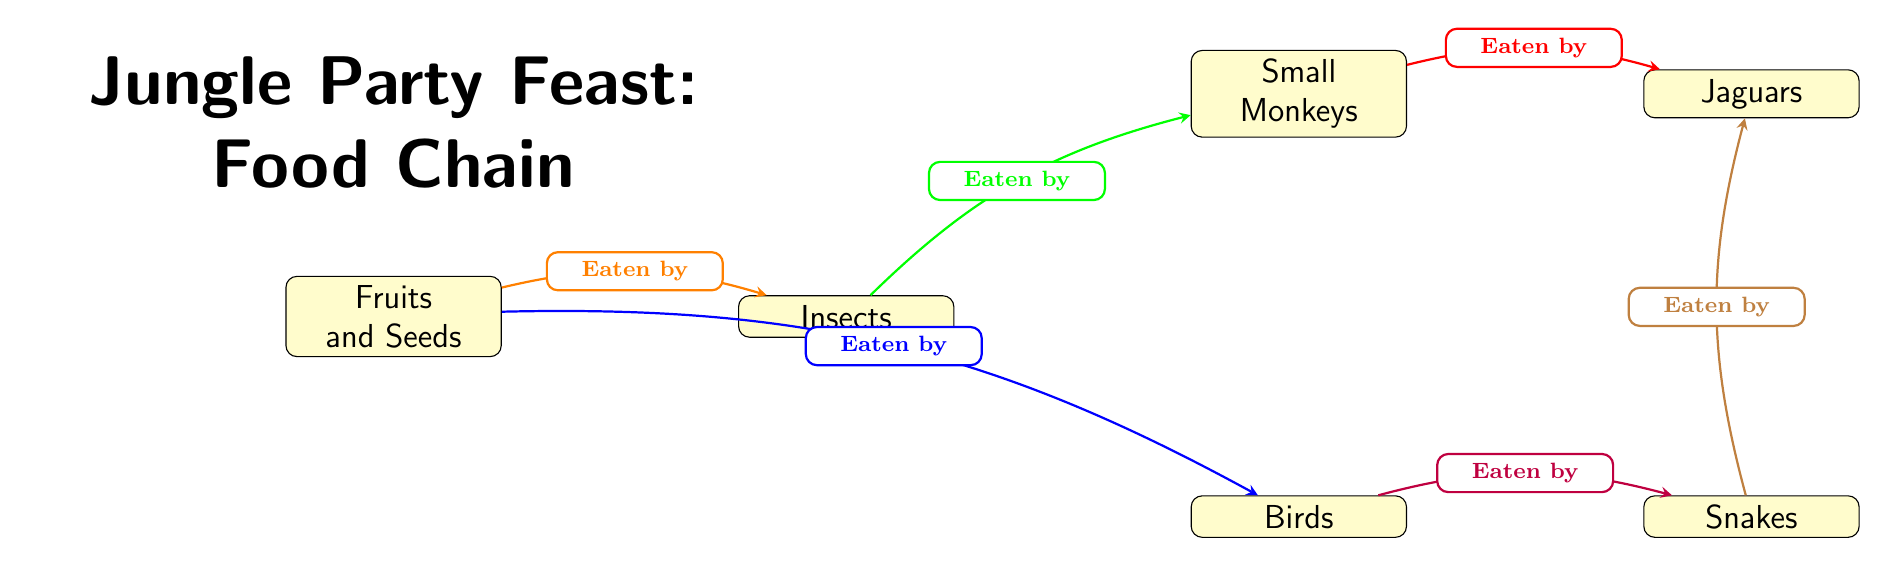What's at the top of the food chain? The diagram shows that Jaguars are positioned at the top of the food chain, indicating they are the largest predators.
Answer: Jaguars How many nodes are in the food chain? Counting each of the distinct entities in the diagram, we identify Fruits and Seeds, Insects, Small Monkeys, Birds, Snakes, and Jaguars, which totals six nodes.
Answer: 6 What do insects eat? Referring to the diagram, it's clear that Insects eat Fruits and Seeds, which is indicated by the arrow pointing from Fruits and Seeds to Insects.
Answer: Fruits and Seeds Which animals eat birds? The diagram indicates that Snakes are the animals that eat Birds, as shown by the arrow connecting Birds to Snakes.
Answer: Snakes What is the relationship between Small Monkeys and Jaguars? Small Monkeys are eaten by Jaguars, as indicated by the arrow leading from Small Monkeys to Jaguars, representing the predator-prey relationship.
Answer: Eaten by What two animals can Jaguars eat? The diagram shows Jaguars can eat both Small Monkeys and Snakes, represented by arrows pointing from these two animals to Jaguars.
Answer: Small Monkeys and Snakes Which animal eats both fruits and seeds and small monkeys? Insects eat Fruits and Seeds and are in turn eaten by Small Monkeys. Therefore, the relationship shows that Insects depend on Fruits and Seeds while providing food for Small Monkeys.
Answer: Insects How many directions do arrows point from Fruits and Seeds? There are two arrows pointing from Fruits and Seeds: one towards Insects and another towards Birds, indicating two relationships with these animals.
Answer: 2 